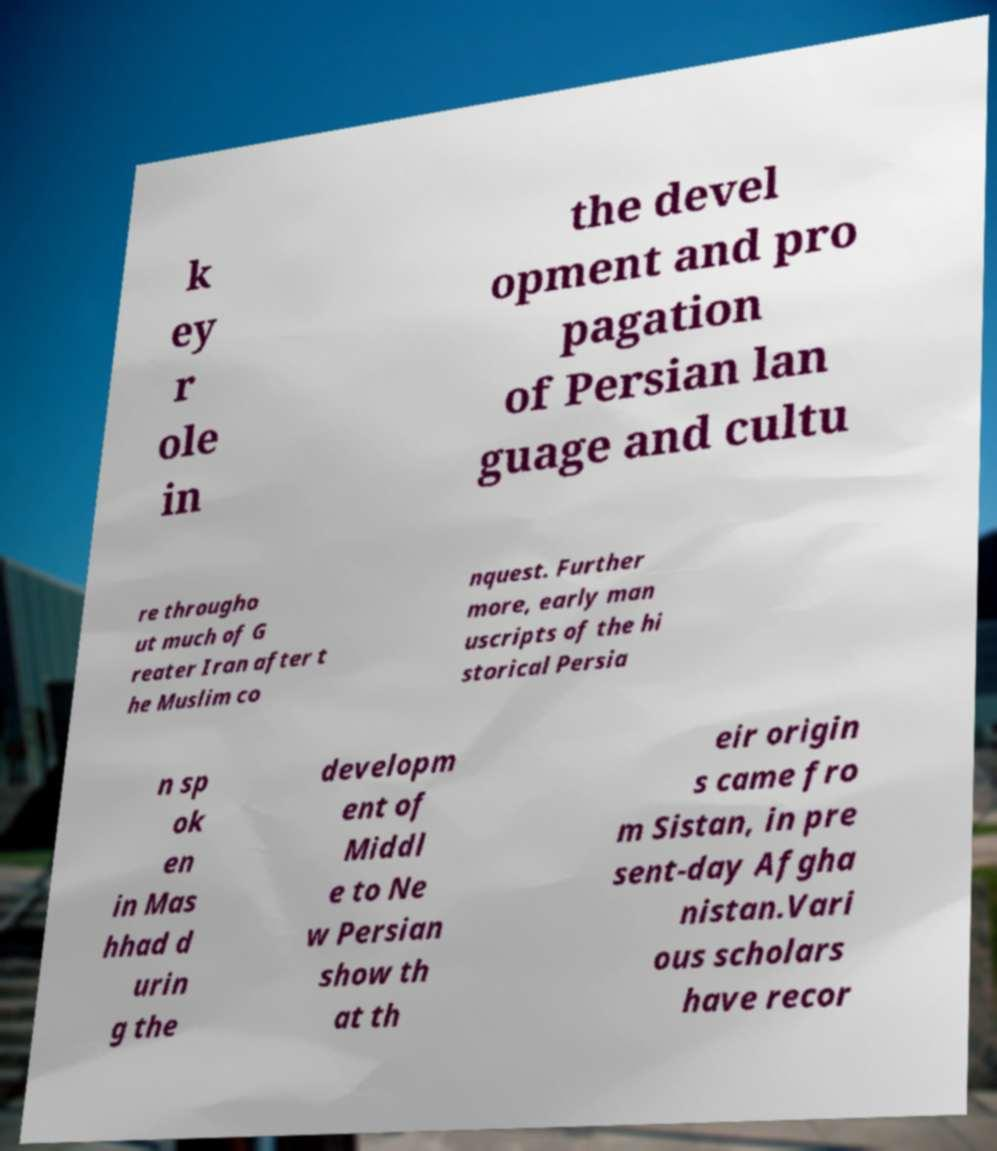Could you assist in decoding the text presented in this image and type it out clearly? k ey r ole in the devel opment and pro pagation of Persian lan guage and cultu re througho ut much of G reater Iran after t he Muslim co nquest. Further more, early man uscripts of the hi storical Persia n sp ok en in Mas hhad d urin g the developm ent of Middl e to Ne w Persian show th at th eir origin s came fro m Sistan, in pre sent-day Afgha nistan.Vari ous scholars have recor 